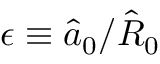Convert formula to latex. <formula><loc_0><loc_0><loc_500><loc_500>\epsilon \equiv \hat { a } _ { 0 } / \hat { R } _ { 0 }</formula> 